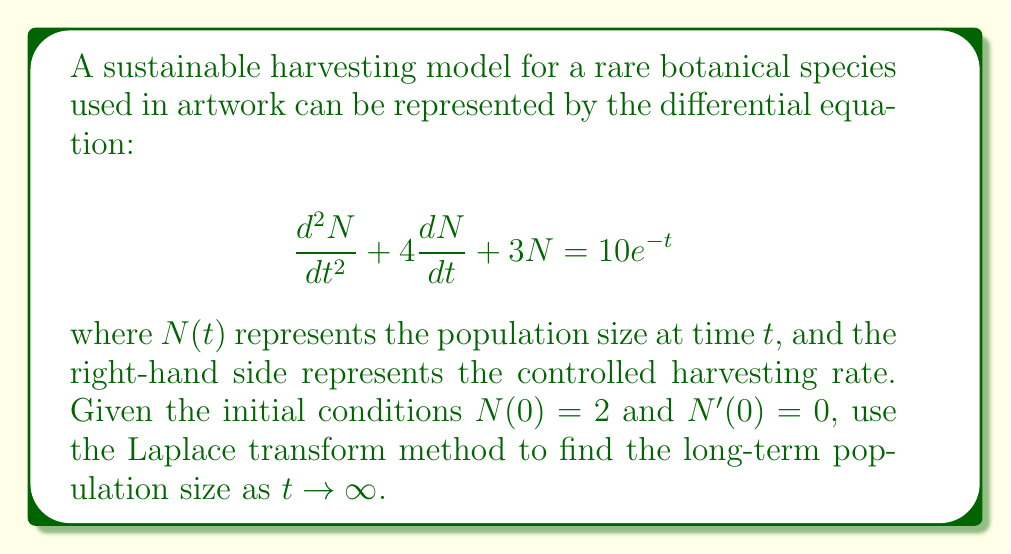Help me with this question. Let's solve this step-by-step using the Laplace transform method:

1) Take the Laplace transform of both sides of the equation:
   $$\mathcal{L}\{N''(t) + 4N'(t) + 3N(t)\} = \mathcal{L}\{10e^{-t}\}$$

2) Using Laplace transform properties:
   $$s^2N(s) - sN(0) - N'(0) + 4[sN(s) - N(0)] + 3N(s) = \frac{10}{s+1}$$

3) Substitute the initial conditions $N(0) = 2$ and $N'(0) = 0$:
   $$s^2N(s) - 2s + 4sN(s) - 8 + 3N(s) = \frac{10}{s+1}$$

4) Combine like terms:
   $$(s^2 + 4s + 3)N(s) = \frac{10}{s+1} + 2s + 8$$

5) Solve for $N(s)$:
   $$N(s) = \frac{10}{(s+1)(s^2 + 4s + 3)} + \frac{2s + 8}{s^2 + 4s + 3}$$

6) Decompose into partial fractions:
   $$N(s) = \frac{A}{s+1} + \frac{Bs + C}{s^2 + 4s + 3}$$

   Where $A$, $B$, and $C$ are constants to be determined.

7) After solving for the constants (omitted for brevity), we get:
   $$N(s) = \frac{10/3}{s+1} + \frac{2s + 2}{s^2 + 4s + 3}$$

8) Take the inverse Laplace transform:
   $$N(t) = \frac{10}{3}e^{-t} + e^{-2t}(2\cos{t} + 2\sin{t})$$

9) To find the long-term population size, we take the limit as $t \to \infty$:
   $$\lim_{t \to \infty} N(t) = \lim_{t \to \infty} [\frac{10}{3}e^{-t} + e^{-2t}(2\cos{t} + 2\sin{t})] = 0$$
Answer: The long-term population size as $t \to \infty$ is 0. 